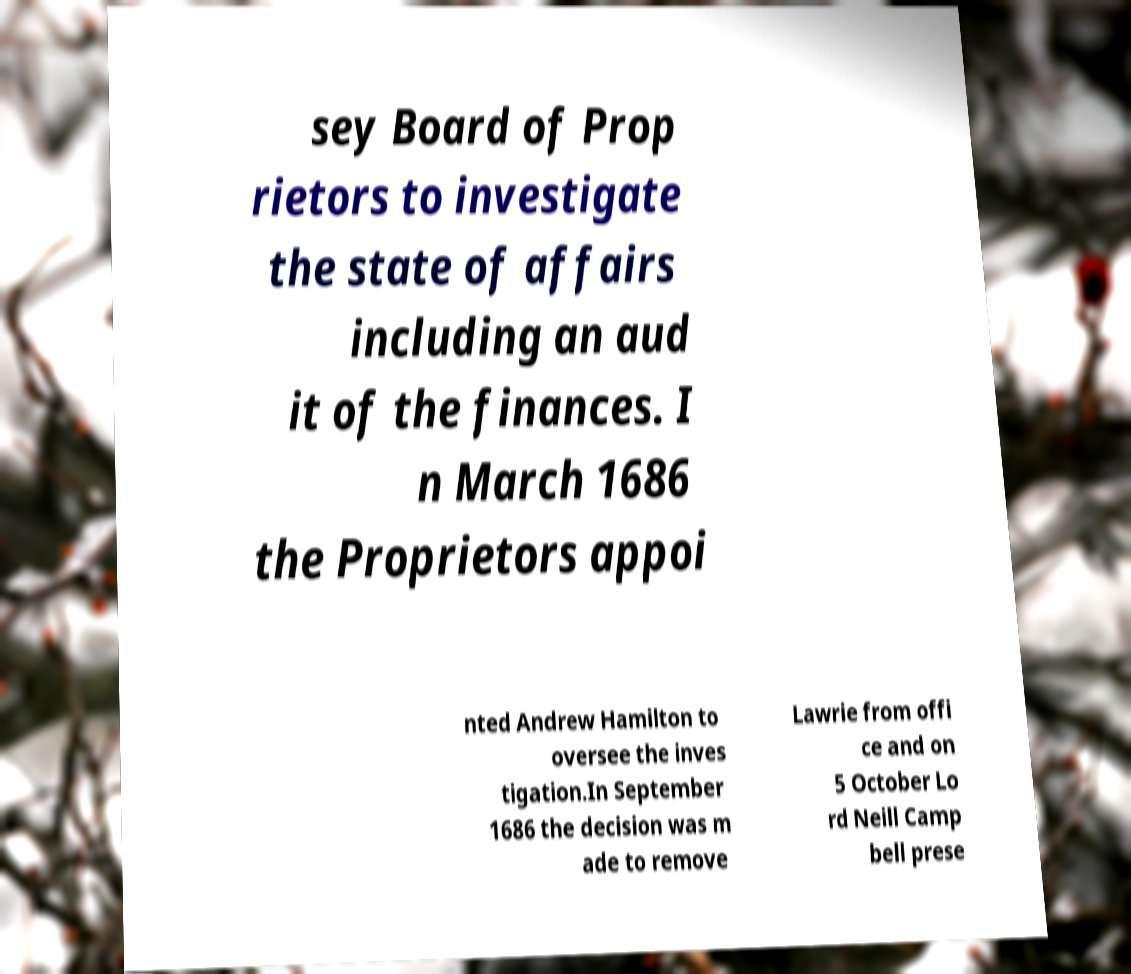What messages or text are displayed in this image? I need them in a readable, typed format. sey Board of Prop rietors to investigate the state of affairs including an aud it of the finances. I n March 1686 the Proprietors appoi nted Andrew Hamilton to oversee the inves tigation.In September 1686 the decision was m ade to remove Lawrie from offi ce and on 5 October Lo rd Neill Camp bell prese 